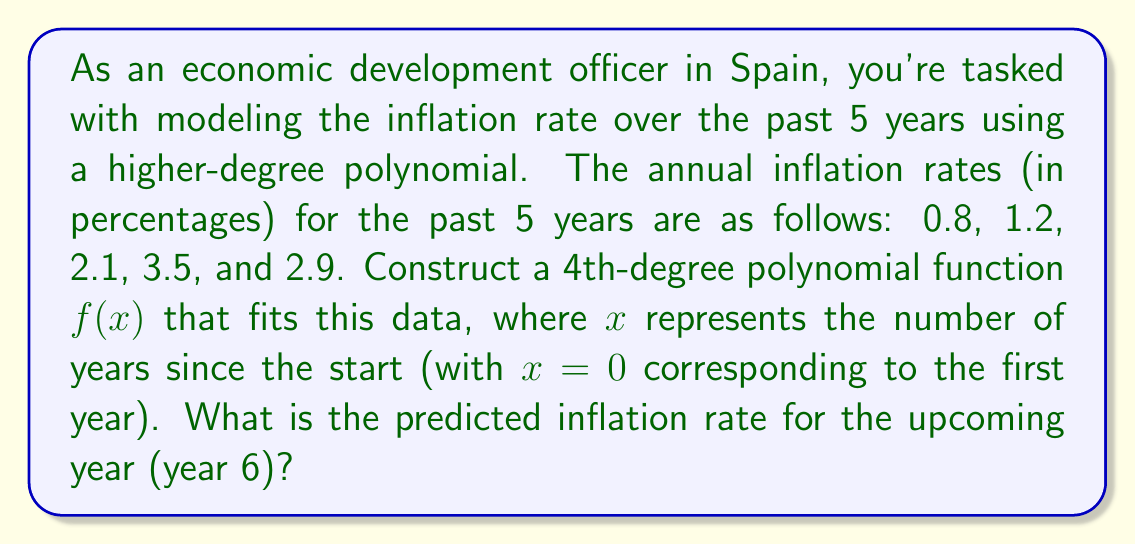What is the answer to this math problem? To solve this problem, we'll follow these steps:

1) First, we need to set up a system of equations using the given data points:
   $f(0) = 0.8$
   $f(1) = 1.2$
   $f(2) = 2.1$
   $f(3) = 3.5$
   $f(4) = 2.9$

2) The general form of a 4th-degree polynomial is:
   $f(x) = ax^4 + bx^3 + cx^2 + dx + e$

3) Substituting our data points into this equation gives us:
   $0.8 = e$
   $1.2 = a + b + c + d + 0.8$
   $2.1 = 16a + 8b + 4c + 2d + 0.8$
   $3.5 = 81a + 27b + 9c + 3d + 0.8$
   $2.9 = 256a + 64b + 16c + 4d + 0.8$

4) Solving this system of equations (which can be done using a computer algebra system due to its complexity) yields:
   $a = -0.0391667$
   $b = 0.3458333$
   $c = -0.8875$
   $d = 0.9708333$
   $e = 0.8$

5) Therefore, our polynomial function is:
   $f(x) = -0.0391667x^4 + 0.3458333x^3 - 0.8875x^2 + 0.9708333x + 0.8$

6) To predict the inflation rate for year 6, we need to calculate $f(5)$:
   $f(5) = -0.0391667(5^4) + 0.3458333(5^3) - 0.8875(5^2) + 0.9708333(5) + 0.8$
   $     = -24.4791688 + 43.2291663 - 22.1875 + 4.8541665 + 0.8$
   $     = 2.2166640$
Answer: The predicted inflation rate for year 6 is approximately 2.22%. 